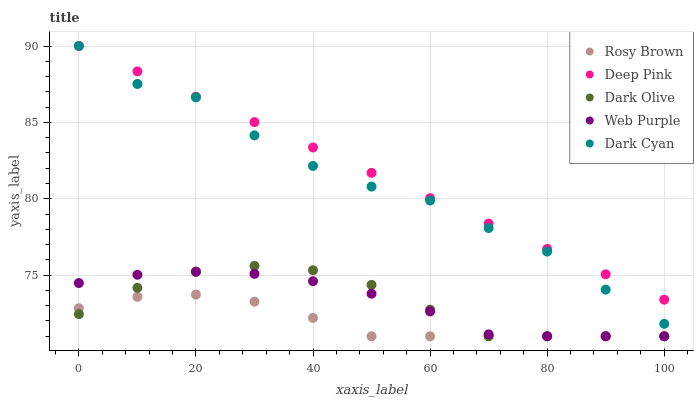Does Rosy Brown have the minimum area under the curve?
Answer yes or no. Yes. Does Deep Pink have the maximum area under the curve?
Answer yes or no. Yes. Does Dark Cyan have the minimum area under the curve?
Answer yes or no. No. Does Dark Cyan have the maximum area under the curve?
Answer yes or no. No. Is Deep Pink the smoothest?
Answer yes or no. Yes. Is Dark Cyan the roughest?
Answer yes or no. Yes. Is Web Purple the smoothest?
Answer yes or no. No. Is Web Purple the roughest?
Answer yes or no. No. Does Dark Olive have the lowest value?
Answer yes or no. Yes. Does Dark Cyan have the lowest value?
Answer yes or no. No. Does Deep Pink have the highest value?
Answer yes or no. Yes. Does Web Purple have the highest value?
Answer yes or no. No. Is Rosy Brown less than Deep Pink?
Answer yes or no. Yes. Is Dark Cyan greater than Rosy Brown?
Answer yes or no. Yes. Does Rosy Brown intersect Dark Olive?
Answer yes or no. Yes. Is Rosy Brown less than Dark Olive?
Answer yes or no. No. Is Rosy Brown greater than Dark Olive?
Answer yes or no. No. Does Rosy Brown intersect Deep Pink?
Answer yes or no. No. 